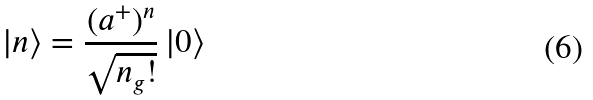<formula> <loc_0><loc_0><loc_500><loc_500>\left | n \right \rangle = \frac { ( a ^ { + } ) ^ { n } } { \sqrt { n _ { g } ! } } \left | 0 \right \rangle</formula> 